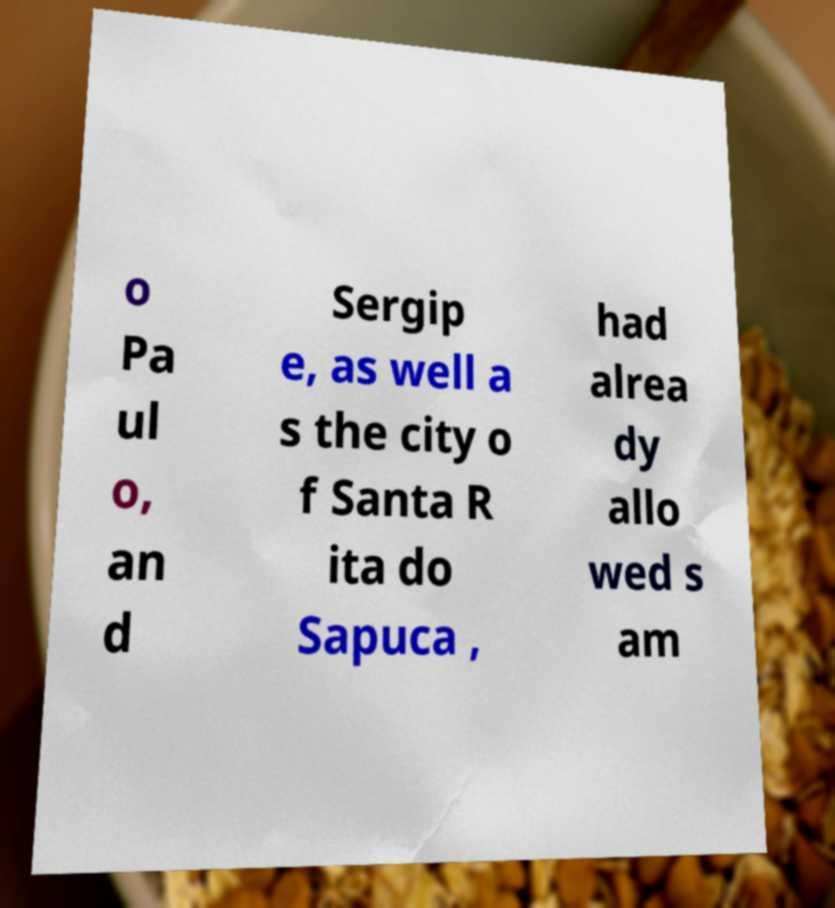Could you extract and type out the text from this image? o Pa ul o, an d Sergip e, as well a s the city o f Santa R ita do Sapuca , had alrea dy allo wed s am 